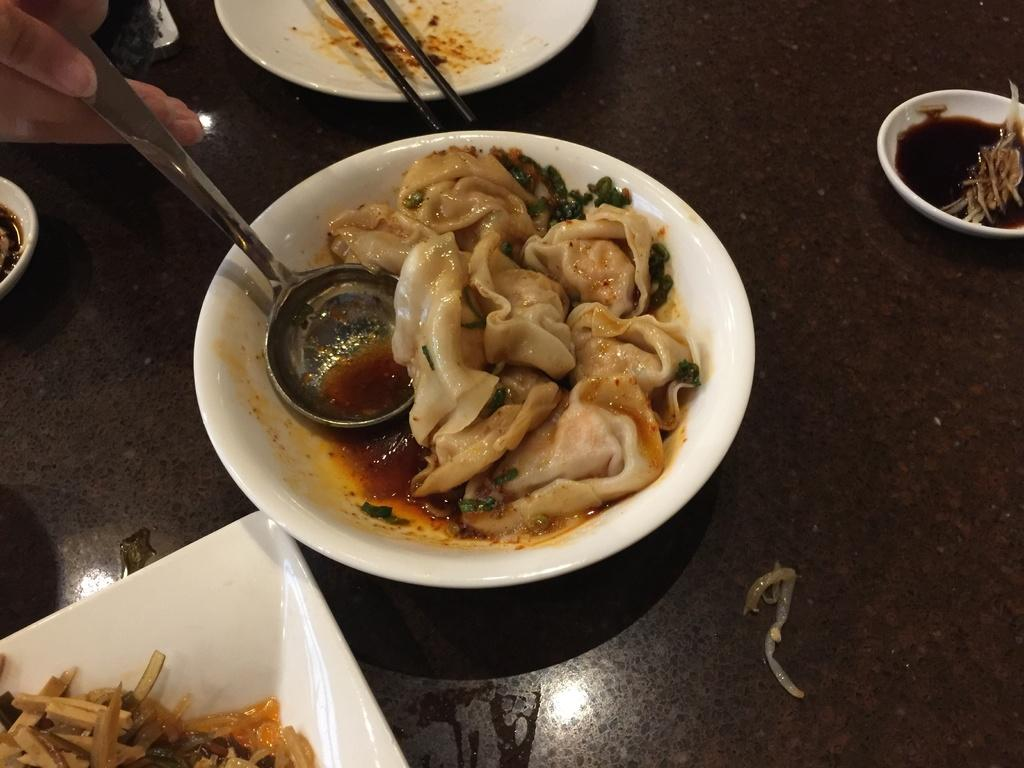What is on the plate that is visible in the image? There is food in a plate in the image. What else can be seen in the image besides the plate of food? A human hand is visible in the top left hand side of the image, and the person is holding a spoon. How many plates are visible in the image? There are additional plates around the middle plate. What type of stamp can be seen on the plate in the image? There is no stamp present on the plate in the image; it contains food. 